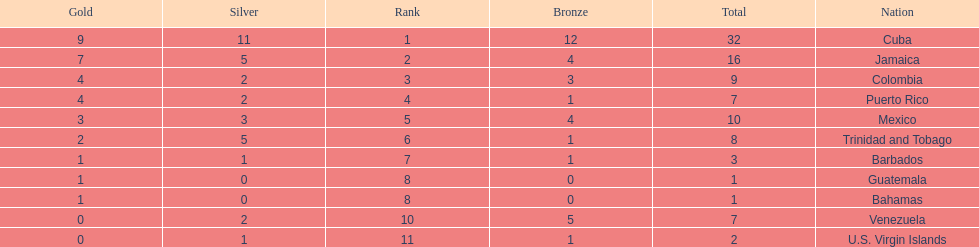What is the total number of gold medals awarded between these 11 countries? 32. 